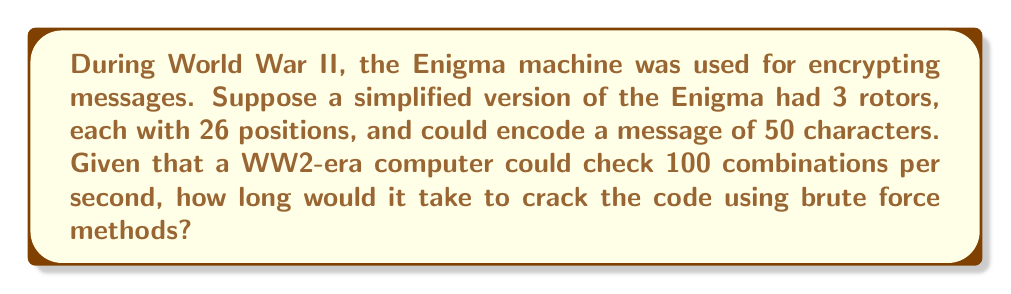Teach me how to tackle this problem. To solve this problem, we need to follow these steps:

1. Calculate the total number of possible combinations:
   - Each rotor has 26 positions
   - There are 3 rotors
   - Total combinations = $26^3 = 17,576$

2. Calculate the number of possible messages:
   - There are 26 choices for each of the 50 characters
   - Total possible messages = $26^{50}$

3. Calculate the total number of possibilities to check:
   - Total possibilities = Rotor combinations × Possible messages
   - $17,576 \times 26^{50}$

4. Calculate the time needed:
   - The computer can check 100 combinations per second
   - Time (in seconds) = $\frac{17,576 \times 26^{50}}{100}$

5. Convert the result to years:
   - Seconds in a year = $365 \times 24 \times 60 \times 60 = 31,536,000$
   - Time (in years) = $\frac{17,576 \times 26^{50}}{100 \times 31,536,000}$

6. Simplify and calculate:
   $$\text{Time (years)} = \frac{17,576 \times 26^{50}}{3,153,600,000} \approx 1.37 \times 10^{73} \text{ years}$$

This astronomical number demonstrates why brute force methods were impractical for cracking Enigma codes, highlighting the importance of other cryptanalysis techniques developed during World War II.
Answer: $1.37 \times 10^{73}$ years 